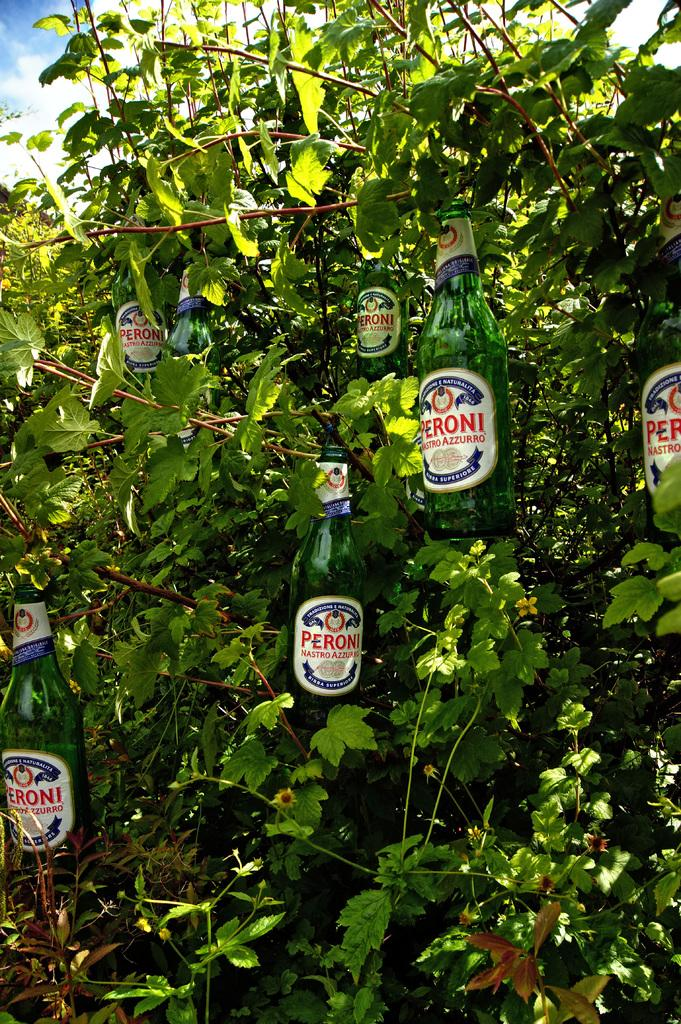What objects are in the image with stickers on them? There are bottles with stickers in the image. How are the bottles positioned in the image? The bottles are hanged on a tree. What can be seen in the background of the image? Sky is visible in the background of the image. What type of weather can be inferred from the image? Clouds are present in the sky, suggesting a partly cloudy day. What is the topic of the heated argument taking place in the image? There is no heated argument present in the image; it features bottles with stickers hanging on a tree with clouds in the sky. What type of vessel is being used to transport water in the image? There is no vessel present in the image for transporting water; it only features bottles with stickers hanging on a tree. 